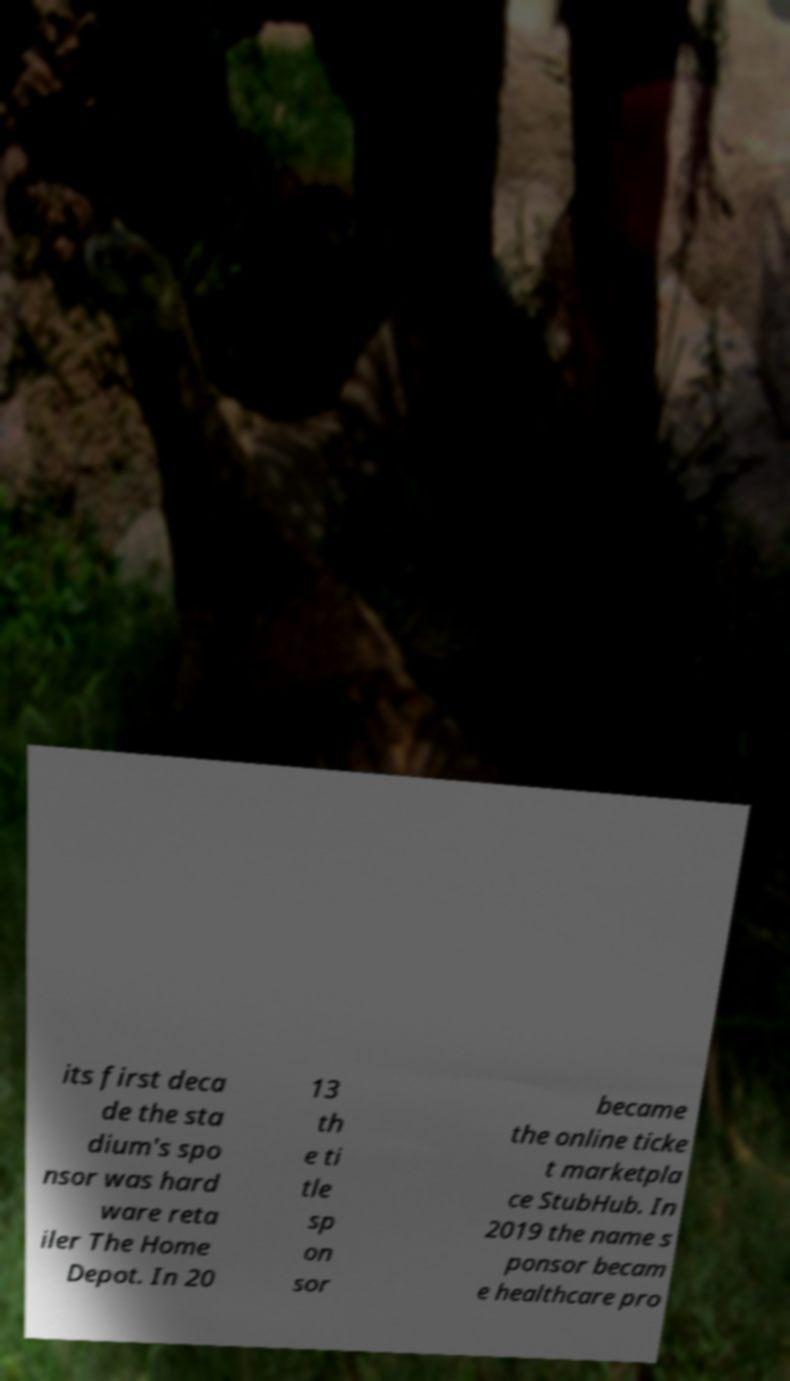Can you read and provide the text displayed in the image?This photo seems to have some interesting text. Can you extract and type it out for me? its first deca de the sta dium's spo nsor was hard ware reta iler The Home Depot. In 20 13 th e ti tle sp on sor became the online ticke t marketpla ce StubHub. In 2019 the name s ponsor becam e healthcare pro 